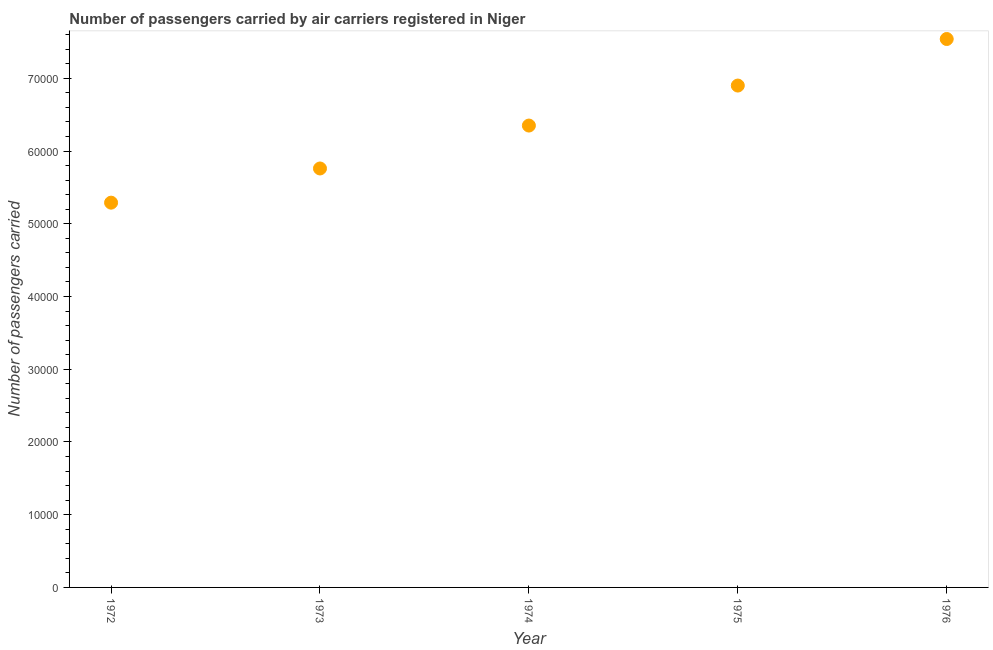What is the number of passengers carried in 1975?
Make the answer very short. 6.90e+04. Across all years, what is the maximum number of passengers carried?
Your response must be concise. 7.54e+04. Across all years, what is the minimum number of passengers carried?
Provide a short and direct response. 5.29e+04. In which year was the number of passengers carried maximum?
Provide a short and direct response. 1976. In which year was the number of passengers carried minimum?
Ensure brevity in your answer.  1972. What is the sum of the number of passengers carried?
Offer a very short reply. 3.18e+05. What is the difference between the number of passengers carried in 1972 and 1974?
Provide a short and direct response. -1.06e+04. What is the average number of passengers carried per year?
Provide a short and direct response. 6.37e+04. What is the median number of passengers carried?
Provide a succinct answer. 6.35e+04. In how many years, is the number of passengers carried greater than 28000 ?
Provide a short and direct response. 5. What is the ratio of the number of passengers carried in 1975 to that in 1976?
Your response must be concise. 0.92. Is the number of passengers carried in 1972 less than that in 1975?
Your answer should be compact. Yes. Is the difference between the number of passengers carried in 1973 and 1976 greater than the difference between any two years?
Your response must be concise. No. What is the difference between the highest and the second highest number of passengers carried?
Keep it short and to the point. 6400. Is the sum of the number of passengers carried in 1974 and 1975 greater than the maximum number of passengers carried across all years?
Your answer should be compact. Yes. What is the difference between the highest and the lowest number of passengers carried?
Ensure brevity in your answer.  2.25e+04. Are the values on the major ticks of Y-axis written in scientific E-notation?
Give a very brief answer. No. Does the graph contain grids?
Keep it short and to the point. No. What is the title of the graph?
Provide a succinct answer. Number of passengers carried by air carriers registered in Niger. What is the label or title of the X-axis?
Your response must be concise. Year. What is the label or title of the Y-axis?
Make the answer very short. Number of passengers carried. What is the Number of passengers carried in 1972?
Offer a very short reply. 5.29e+04. What is the Number of passengers carried in 1973?
Your response must be concise. 5.76e+04. What is the Number of passengers carried in 1974?
Your response must be concise. 6.35e+04. What is the Number of passengers carried in 1975?
Ensure brevity in your answer.  6.90e+04. What is the Number of passengers carried in 1976?
Offer a terse response. 7.54e+04. What is the difference between the Number of passengers carried in 1972 and 1973?
Ensure brevity in your answer.  -4700. What is the difference between the Number of passengers carried in 1972 and 1974?
Keep it short and to the point. -1.06e+04. What is the difference between the Number of passengers carried in 1972 and 1975?
Your answer should be compact. -1.61e+04. What is the difference between the Number of passengers carried in 1972 and 1976?
Provide a succinct answer. -2.25e+04. What is the difference between the Number of passengers carried in 1973 and 1974?
Make the answer very short. -5900. What is the difference between the Number of passengers carried in 1973 and 1975?
Offer a very short reply. -1.14e+04. What is the difference between the Number of passengers carried in 1973 and 1976?
Your response must be concise. -1.78e+04. What is the difference between the Number of passengers carried in 1974 and 1975?
Keep it short and to the point. -5500. What is the difference between the Number of passengers carried in 1974 and 1976?
Offer a terse response. -1.19e+04. What is the difference between the Number of passengers carried in 1975 and 1976?
Keep it short and to the point. -6400. What is the ratio of the Number of passengers carried in 1972 to that in 1973?
Keep it short and to the point. 0.92. What is the ratio of the Number of passengers carried in 1972 to that in 1974?
Offer a very short reply. 0.83. What is the ratio of the Number of passengers carried in 1972 to that in 1975?
Your response must be concise. 0.77. What is the ratio of the Number of passengers carried in 1972 to that in 1976?
Provide a short and direct response. 0.7. What is the ratio of the Number of passengers carried in 1973 to that in 1974?
Ensure brevity in your answer.  0.91. What is the ratio of the Number of passengers carried in 1973 to that in 1975?
Provide a succinct answer. 0.83. What is the ratio of the Number of passengers carried in 1973 to that in 1976?
Your answer should be very brief. 0.76. What is the ratio of the Number of passengers carried in 1974 to that in 1975?
Offer a very short reply. 0.92. What is the ratio of the Number of passengers carried in 1974 to that in 1976?
Offer a very short reply. 0.84. What is the ratio of the Number of passengers carried in 1975 to that in 1976?
Give a very brief answer. 0.92. 